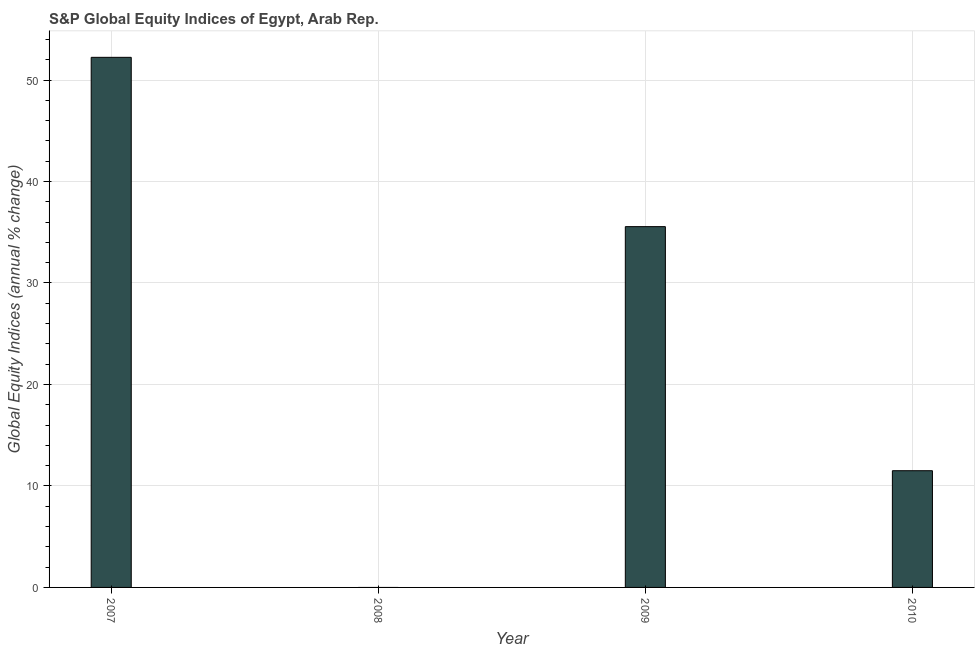Does the graph contain any zero values?
Offer a terse response. Yes. Does the graph contain grids?
Keep it short and to the point. Yes. What is the title of the graph?
Give a very brief answer. S&P Global Equity Indices of Egypt, Arab Rep. What is the label or title of the X-axis?
Your answer should be very brief. Year. What is the label or title of the Y-axis?
Keep it short and to the point. Global Equity Indices (annual % change). What is the s&p global equity indices in 2007?
Keep it short and to the point. 52.24. Across all years, what is the maximum s&p global equity indices?
Keep it short and to the point. 52.24. Across all years, what is the minimum s&p global equity indices?
Provide a succinct answer. 0. What is the sum of the s&p global equity indices?
Make the answer very short. 99.29. What is the difference between the s&p global equity indices in 2009 and 2010?
Give a very brief answer. 24.05. What is the average s&p global equity indices per year?
Provide a short and direct response. 24.82. What is the median s&p global equity indices?
Give a very brief answer. 23.53. In how many years, is the s&p global equity indices greater than 48 %?
Ensure brevity in your answer.  1. What is the ratio of the s&p global equity indices in 2007 to that in 2010?
Your answer should be compact. 4.54. What is the difference between the highest and the second highest s&p global equity indices?
Ensure brevity in your answer.  16.68. What is the difference between the highest and the lowest s&p global equity indices?
Your answer should be very brief. 52.24. In how many years, is the s&p global equity indices greater than the average s&p global equity indices taken over all years?
Your response must be concise. 2. How many bars are there?
Make the answer very short. 3. Are all the bars in the graph horizontal?
Provide a succinct answer. No. How many years are there in the graph?
Ensure brevity in your answer.  4. What is the difference between two consecutive major ticks on the Y-axis?
Provide a succinct answer. 10. Are the values on the major ticks of Y-axis written in scientific E-notation?
Provide a short and direct response. No. What is the Global Equity Indices (annual % change) of 2007?
Give a very brief answer. 52.24. What is the Global Equity Indices (annual % change) in 2009?
Provide a short and direct response. 35.55. What is the Global Equity Indices (annual % change) in 2010?
Your answer should be very brief. 11.5. What is the difference between the Global Equity Indices (annual % change) in 2007 and 2009?
Make the answer very short. 16.68. What is the difference between the Global Equity Indices (annual % change) in 2007 and 2010?
Your answer should be compact. 40.74. What is the difference between the Global Equity Indices (annual % change) in 2009 and 2010?
Provide a short and direct response. 24.05. What is the ratio of the Global Equity Indices (annual % change) in 2007 to that in 2009?
Give a very brief answer. 1.47. What is the ratio of the Global Equity Indices (annual % change) in 2007 to that in 2010?
Make the answer very short. 4.54. What is the ratio of the Global Equity Indices (annual % change) in 2009 to that in 2010?
Make the answer very short. 3.09. 